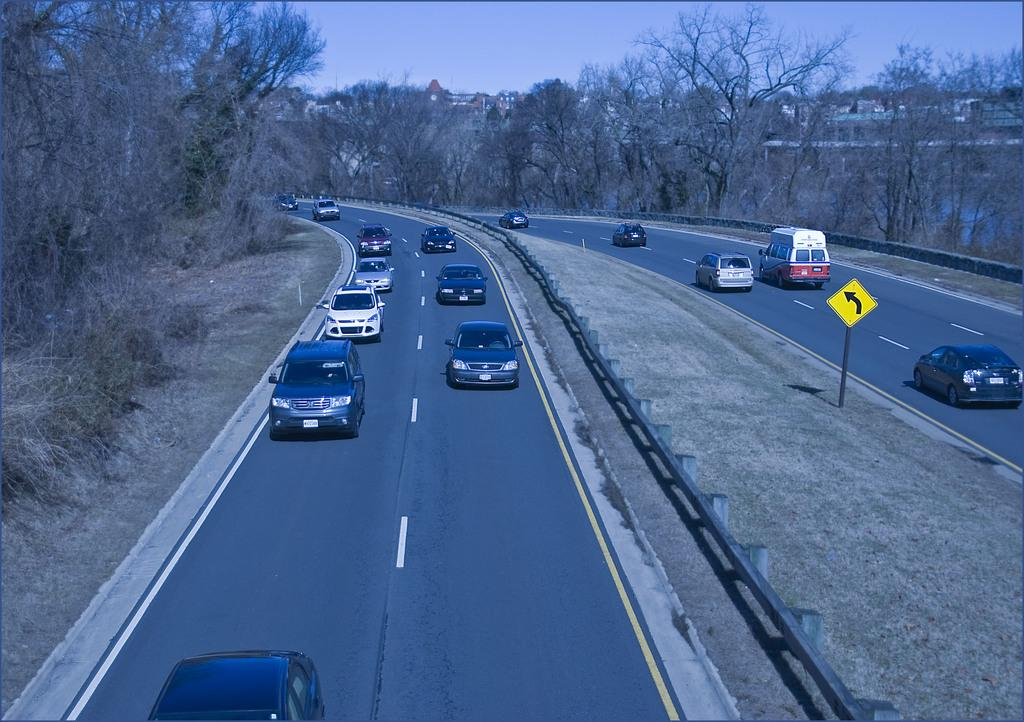What is at the bottom of the image? There is a road at the bottom of the image. What types of vehicles can be seen on the road? Cars and vans are present on the road. What is located in the image besides the road and vehicles? There is a sign board, trees, buildings, and the sky visible in the background of the image. Where is the meeting taking place in the image? There is no meeting present in the image. What type of honey can be seen dripping from the sign board in the image? There is no honey present in the image. 